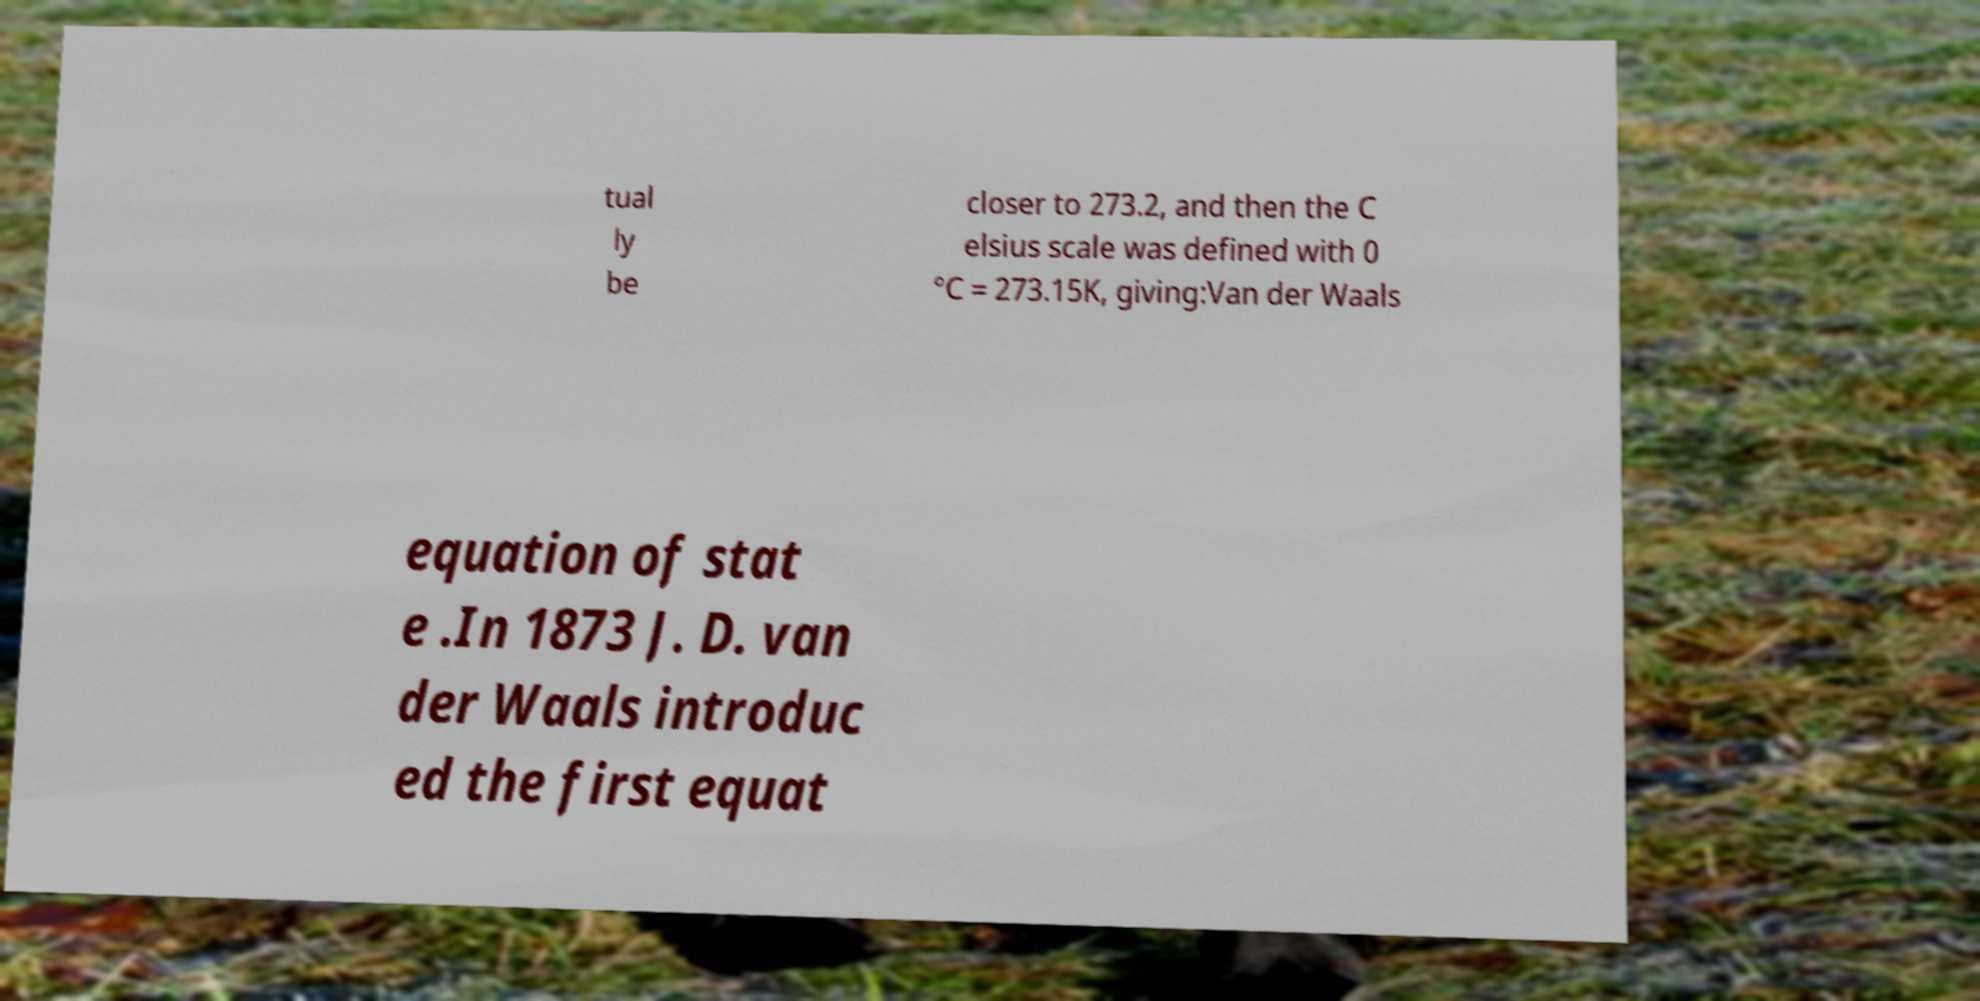Can you accurately transcribe the text from the provided image for me? tual ly be closer to 273.2, and then the C elsius scale was defined with 0 °C = 273.15K, giving:Van der Waals equation of stat e .In 1873 J. D. van der Waals introduc ed the first equat 